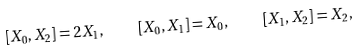Convert formula to latex. <formula><loc_0><loc_0><loc_500><loc_500>[ X _ { 0 } , X _ { 2 } ] = 2 X _ { 1 } , \quad [ X _ { 0 } , X _ { 1 } ] = X _ { 0 } , \quad [ X _ { 1 } , X _ { 2 } ] = X _ { 2 } ,</formula> 